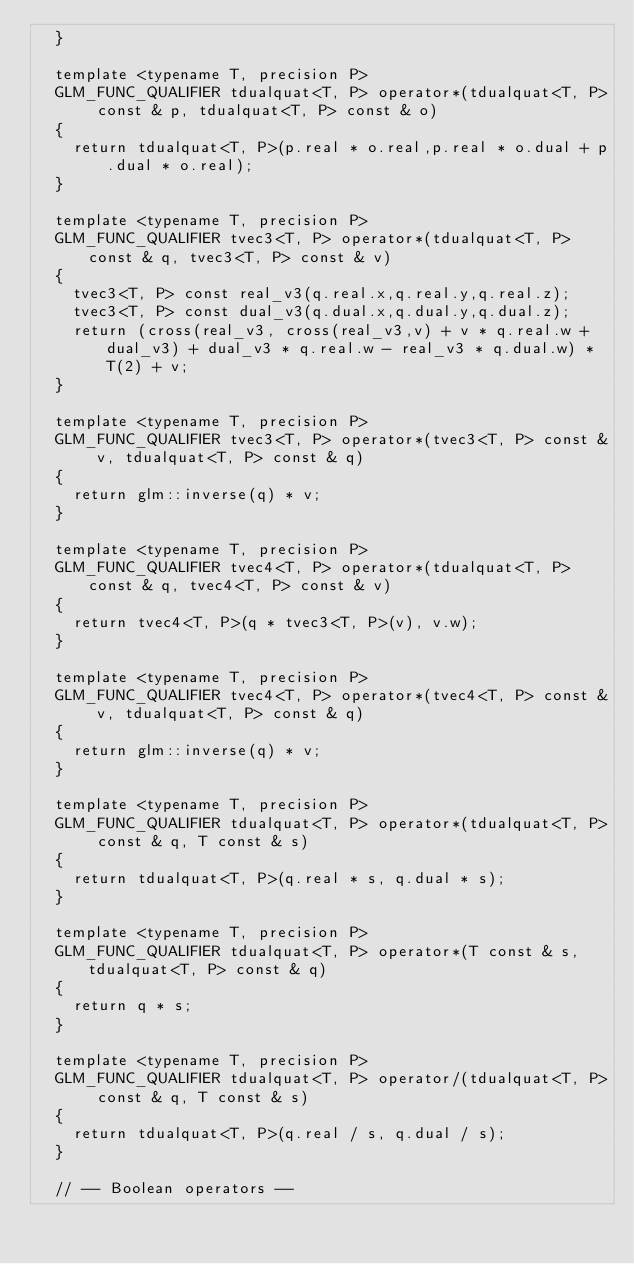<code> <loc_0><loc_0><loc_500><loc_500><_C++_>	}

	template <typename T, precision P>
	GLM_FUNC_QUALIFIER tdualquat<T, P> operator*(tdualquat<T, P> const & p, tdualquat<T, P> const & o)
	{
		return tdualquat<T, P>(p.real * o.real,p.real * o.dual + p.dual * o.real);
	}

	template <typename T, precision P>
	GLM_FUNC_QUALIFIER tvec3<T, P> operator*(tdualquat<T, P> const & q, tvec3<T, P> const & v)
	{
		tvec3<T, P> const real_v3(q.real.x,q.real.y,q.real.z);
		tvec3<T, P> const dual_v3(q.dual.x,q.dual.y,q.dual.z);
		return (cross(real_v3, cross(real_v3,v) + v * q.real.w + dual_v3) + dual_v3 * q.real.w - real_v3 * q.dual.w) * T(2) + v;
	}

	template <typename T, precision P>
	GLM_FUNC_QUALIFIER tvec3<T, P> operator*(tvec3<T, P> const & v,	tdualquat<T, P> const & q)
	{
		return glm::inverse(q) * v;
	}

	template <typename T, precision P>
	GLM_FUNC_QUALIFIER tvec4<T, P> operator*(tdualquat<T, P> const & q, tvec4<T, P> const & v)
	{
		return tvec4<T, P>(q * tvec3<T, P>(v), v.w);
	}

	template <typename T, precision P>
	GLM_FUNC_QUALIFIER tvec4<T, P> operator*(tvec4<T, P> const & v,	tdualquat<T, P> const & q)
	{
		return glm::inverse(q) * v;
	}

	template <typename T, precision P>
	GLM_FUNC_QUALIFIER tdualquat<T, P> operator*(tdualquat<T, P> const & q, T const & s)
	{
		return tdualquat<T, P>(q.real * s, q.dual * s);
	}

	template <typename T, precision P>
	GLM_FUNC_QUALIFIER tdualquat<T, P> operator*(T const & s, tdualquat<T, P> const & q)
	{
		return q * s;
	}

	template <typename T, precision P>
	GLM_FUNC_QUALIFIER tdualquat<T, P> operator/(tdualquat<T, P> const & q,	T const & s)
	{
		return tdualquat<T, P>(q.real / s, q.dual / s);
	}

	// -- Boolean operators --
</code> 